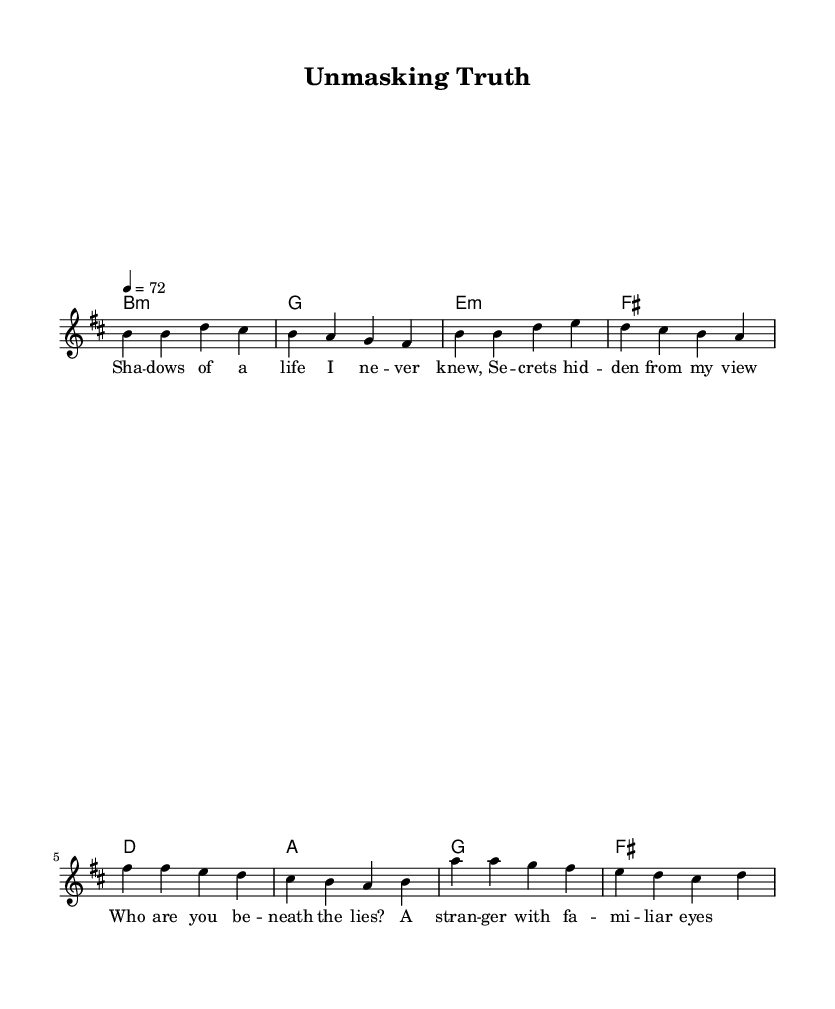What is the key signature of this music? The key signature is indicated as "b minor" in the global settings of the code. The key signature of b minor has two sharps.
Answer: b minor What is the time signature of this music? The time signature is indicated as "4/4" in the global settings of the code. This is a common time signature with four beats per measure.
Answer: 4/4 What is the tempo marking for this piece? The tempo is specified as "4 = 72", meaning there are 72 beats per minute in this piece. This indicates a moderate walking pace.
Answer: 72 How many bars are in the verse section? The verse section contains two lines of music, each with four measures, totaling eight measures in the verse.
Answer: 8 What is the chord progression in the chorus? The chord progression for the chorus is indicated by the harmonies: d, a, g, and fis. These chords create the harmonic foundation for the melody in the chorus section.
Answer: d-a-g-fis What emotional theme is expressed in the lyrics of this piece? The lyrics reflect introspection and a quest for identity, as seen in phrases like "Who are you beneath the lies?" which question one's true self. This aligns with the contemporary R&B theme of self-discovery.
Answer: Introspection What type of music is "Unmasking Truth" categorized as? Based on the combination of its soulful melodies, introspective lyrics, and blending elements of R&B, this piece is categorized as contemporary R&B fusion.
Answer: Contemporary R&B fusion 